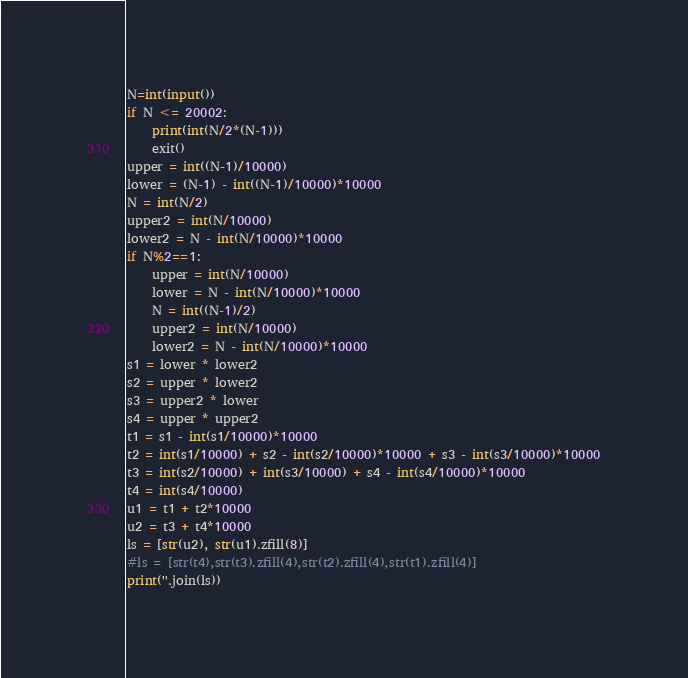<code> <loc_0><loc_0><loc_500><loc_500><_Python_>N=int(input())
if N <= 20002:
    print(int(N/2*(N-1)))
    exit()
upper = int((N-1)/10000)
lower = (N-1) - int((N-1)/10000)*10000
N = int(N/2)
upper2 = int(N/10000)
lower2 = N - int(N/10000)*10000
if N%2==1:
    upper = int(N/10000)
    lower = N - int(N/10000)*10000
    N = int((N-1)/2)
    upper2 = int(N/10000)
    lower2 = N - int(N/10000)*10000
s1 = lower * lower2
s2 = upper * lower2
s3 = upper2 * lower
s4 = upper * upper2
t1 = s1 - int(s1/10000)*10000
t2 = int(s1/10000) + s2 - int(s2/10000)*10000 + s3 - int(s3/10000)*10000
t3 = int(s2/10000) + int(s3/10000) + s4 - int(s4/10000)*10000
t4 = int(s4/10000)
u1 = t1 + t2*10000
u2 = t3 + t4*10000
ls = [str(u2), str(u1).zfill(8)]
#ls = [str(t4),str(t3).zfill(4),str(t2).zfill(4),str(t1).zfill(4)]
print(''.join(ls))
</code> 